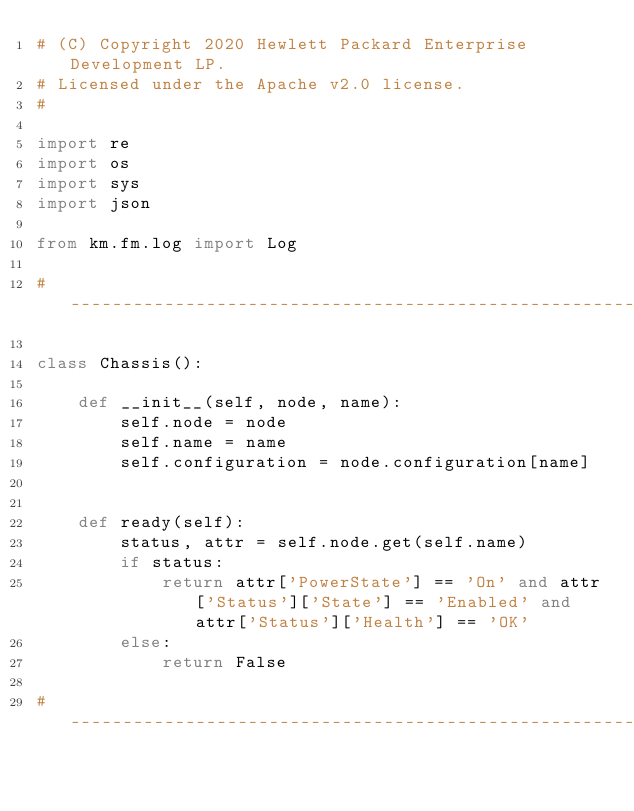Convert code to text. <code><loc_0><loc_0><loc_500><loc_500><_Python_># (C) Copyright 2020 Hewlett Packard Enterprise Development LP.
# Licensed under the Apache v2.0 license.
#

import re
import os
import sys
import json

from km.fm.log import Log

# ----------------------------------------------------------------------------------------------------------------------

class Chassis():

    def __init__(self, node, name):
        self.node = node
        self.name = name
        self.configuration = node.configuration[name]


    def ready(self):
        status, attr = self.node.get(self.name)
        if status:
            return attr['PowerState'] == 'On' and attr['Status']['State'] == 'Enabled' and attr['Status']['Health'] == 'OK'
        else:
            return False

# ----------------------------------------------------------------------------------------------------------------------
</code> 